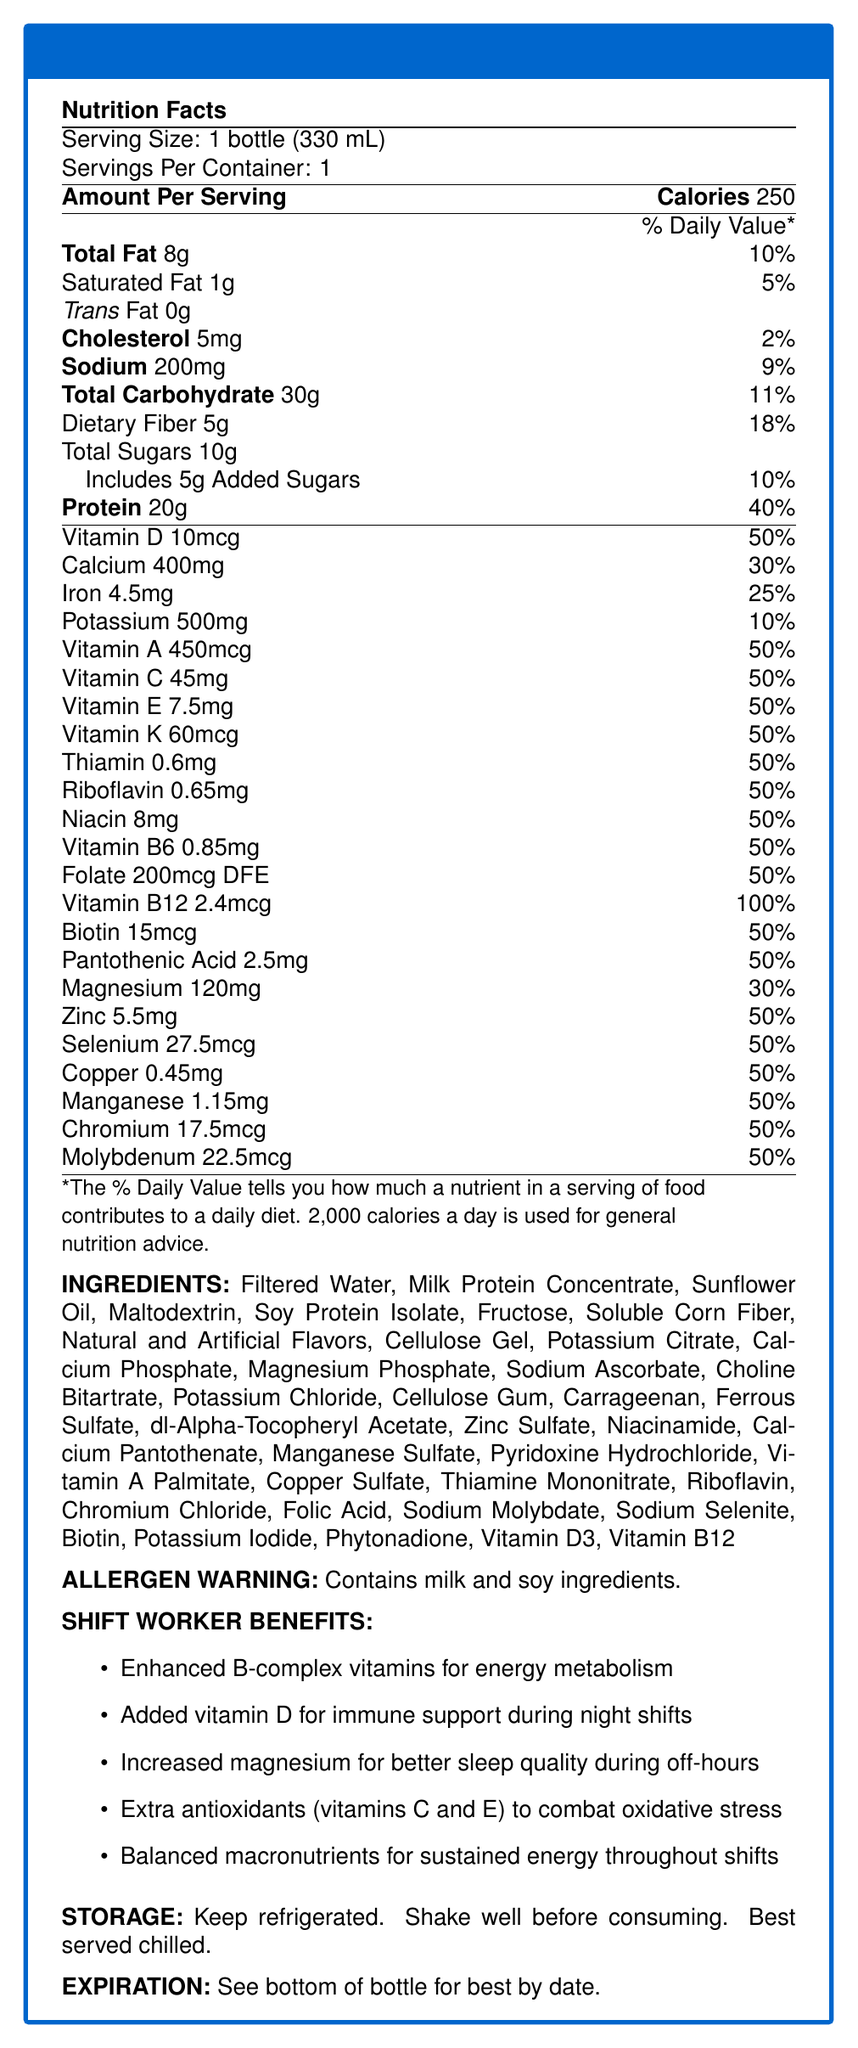what is the serving size of the NightShift Boost Meal Replacement Shake? The serving size is clearly mentioned as "1 bottle (330 mL)" in the document.
Answer: 1 bottle (330 mL) how many calories are in one serving? The document states that there are 250 calories per serving.
Answer: 250 calories what percentage of the daily value is provided by the total fat in one serving? The document specifies that the total fat content is 8g, which corresponds to 10% of the daily value.
Answer: 10% what is the amount of dietary fiber in one serving? The document indicates that there are 5g of dietary fiber in one serving.
Answer: 5g how much protein is in one serving? The protein content per serving is listed as 20g in the document.
Answer: 20g what are the ingredients in the shake? The list of ingredients is provided in the "INGREDIENTS" section of the document.
Answer: Filtered Water, Milk Protein Concentrate, Sunflower Oil, Maltodextrin, Soy Protein Isolate, Fructose, Soluble Corn Fiber, Natural and Artificial Flavors, Cellulose Gel, Potassium Citrate, Calcium Phosphate, Magnesium Phosphate, Sodium Ascorbate, Choline Bitartrate, Potassium Chloride, Cellulose Gum, Carrageenan, Ferrous Sulfate, dl-Alpha-Tocopheryl Acetate, Zinc Sulfate, Niacinamide, Calcium Pantothenate, Manganese Sulfate, Pyridoxine Hydrochloride, Vitamin A Palmitate, Copper Sulfate, Thiamine Mononitrate, Riboflavin, Chromium Chloride, Folic Acid, Sodium Molybdate, Sodium Selenite, Biotin, Potassium Iodide, Phytonadione, Vitamin D3, Vitamin B12 which vitamins in the shake offer 50% of the daily value per serving? 
A. Vitamin K, Vitamin A, Vitamin B12 
B. Vitamin B6, Riboflavin, Vitamin E 
C. Folate, Vitamin D, Vitamin E The document lists Vitamin B6, Riboflavin, and Vitamin E each providing 50% of the daily value.
Answer: B what is the cholesterol content of the shake? 
A. 5mg 
B. 10mg 
C. 15mg 
D. 20mg The document states that the cholesterol content is 5mg per serving.
Answer: A does the shake contain any trans fat? The trans fat content is listed as 0g in the document, indicating there is no trans fat.
Answer: No which minerals provided in the shake have a daily value percentage of 30% or more? The minerals with a daily value percentage of 30% or more are identified in the document's mineral content section.
Answer: Calcium (30%), Magnesium (30%), Iron (25%), Zinc (50%), Selenium (50%) is there any allergen warning mentioned in the document? The document contains an allergen warning stating that the shake contains milk and soy ingredients.
Answer: Yes summarize the main idea of the document. The document provides comprehensive information about the nutrient content, ingredients, specific benefits for shift workers, allergen warnings, and storage guidelines for the NightShift Boost Meal Replacement Shake.
Answer: The NightShift Boost Meal Replacement Shake is a vitamin-fortified beverage designed for shift workers. It contains detailed nutritional information, including vitamins, minerals, and macronutrient content per serving. The document lists ingredients, allergen warnings, and specific benefits for night shift workers, such as enhanced energy metabolism and better sleep quality. Storage instructions are also provided. what is the contact number for customer support? The document does not provide any contact information for customer support.
Answer: Not enough information 